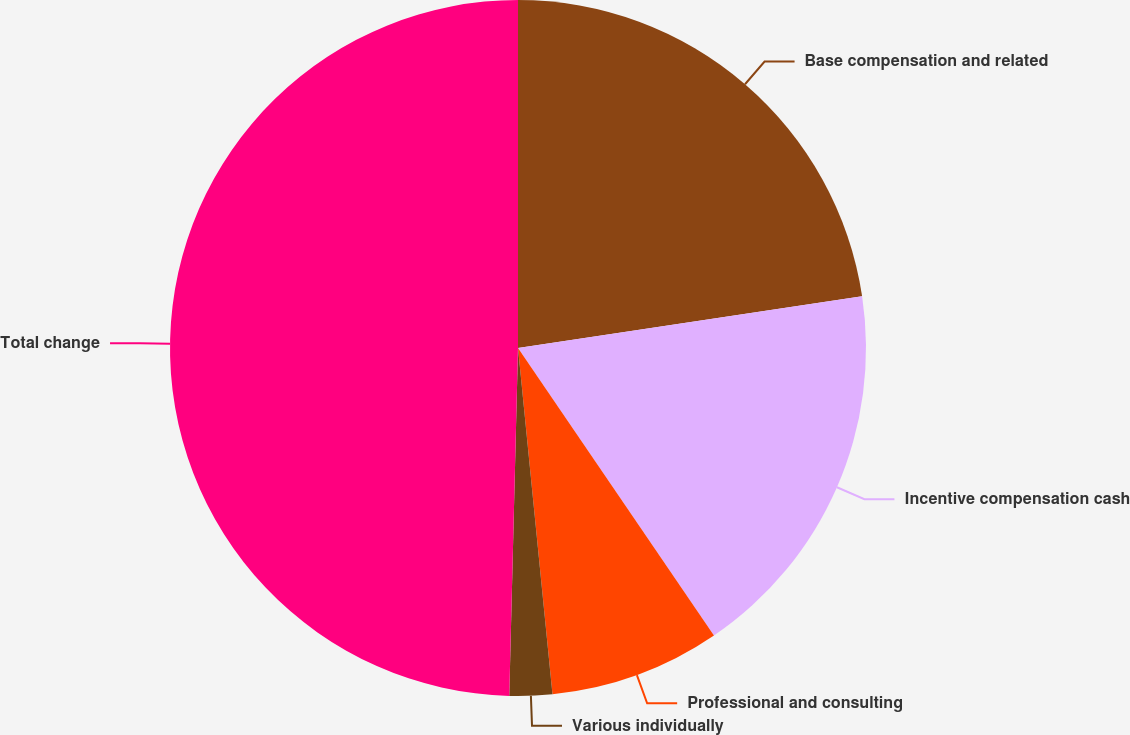Convert chart. <chart><loc_0><loc_0><loc_500><loc_500><pie_chart><fcel>Base compensation and related<fcel>Incentive compensation cash<fcel>Professional and consulting<fcel>Various individually<fcel>Total change<nl><fcel>22.62%<fcel>17.86%<fcel>7.94%<fcel>1.98%<fcel>49.6%<nl></chart> 